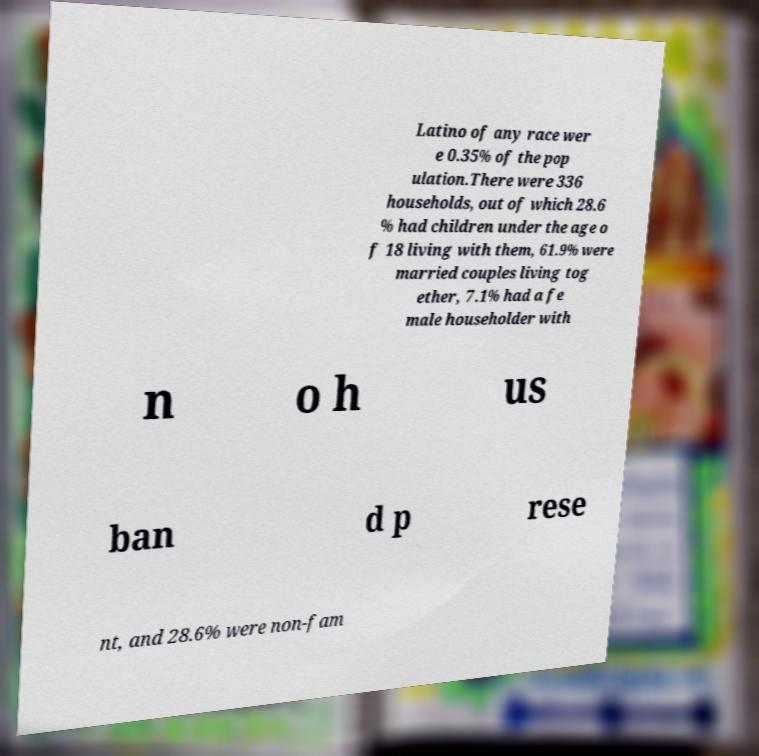Can you accurately transcribe the text from the provided image for me? Latino of any race wer e 0.35% of the pop ulation.There were 336 households, out of which 28.6 % had children under the age o f 18 living with them, 61.9% were married couples living tog ether, 7.1% had a fe male householder with n o h us ban d p rese nt, and 28.6% were non-fam 